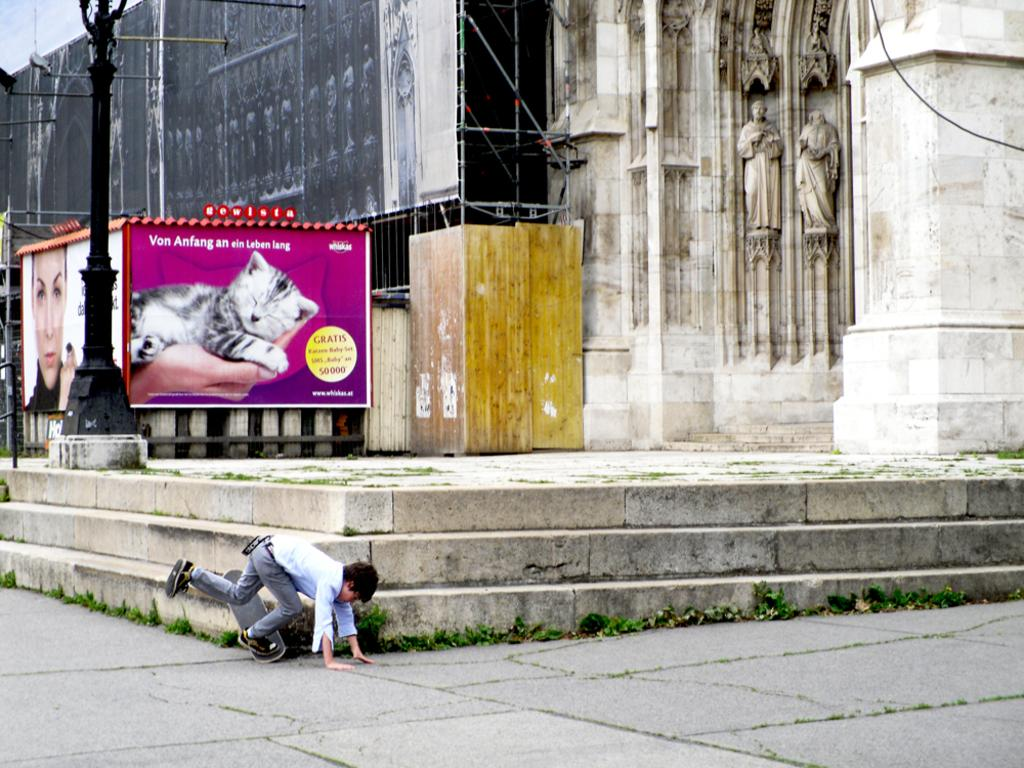What is the main subject of the image? There is a person in the image. What is the person doing in the image? The person has one leg on a skateboard. What can be seen in the background of the image? There are hoardings visible in the image. What is present in the image besides the person and hoardings? There is a pole and statues on a wall in the image. What type of button can be seen on the skateboard in the image? There is no button present on the skateboard in the image. What season is depicted by the spring in the image? There is no spring or any seasonal reference in the image. 